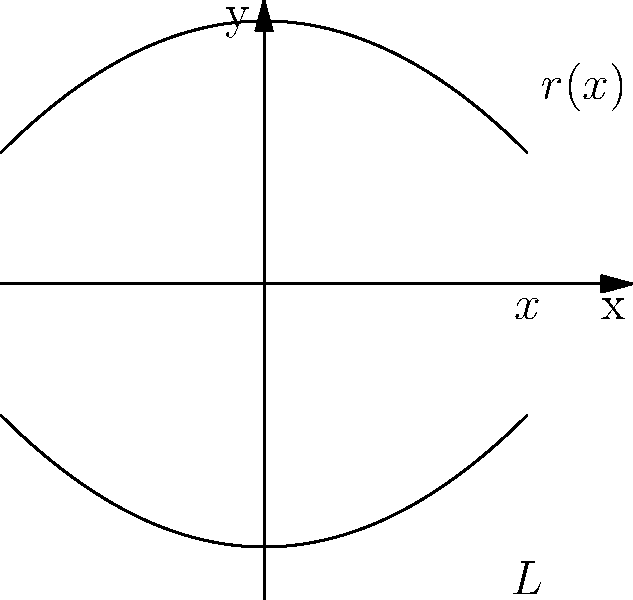A tapered blood vessel can be modeled as a vessel of length $L$ with radius $r(x) = \sqrt{4-x^2}$ mm, where $x$ is the distance along the vessel's axis. The flow rate $Q$ through a circular cross-section is given by $Q = k\pi r^4$, where $k$ is a constant. Determine the total flow rate through the vessel using calculus. To solve this problem, we need to integrate the flow rate over the length of the vessel. Here's a step-by-step approach:

1) The flow rate at any point $x$ is given by:
   $Q(x) = k\pi r(x)^4$

2) Substituting the given function for $r(x)$:
   $Q(x) = k\pi (\sqrt{4-x^2})^4 = k\pi (4-x^2)^2$

3) To find the total flow rate, we need to integrate $Q(x)$ over the length of the vessel:
   $Q_{total} = \int_0^L k\pi (4-x^2)^2 dx$

4) Factor out the constants:
   $Q_{total} = k\pi \int_0^L (4-x^2)^2 dx$

5) Expand $(4-x^2)^2$:
   $(4-x^2)^2 = 16 - 8x^2 + x^4$

6) Now our integral becomes:
   $Q_{total} = k\pi \int_0^L (16 - 8x^2 + x^4) dx$

7) Integrate term by term:
   $Q_{total} = k\pi [16x - \frac{8x^3}{3} + \frac{x^5}{5}]_0^L$

8) Evaluate the integral:
   $Q_{total} = k\pi (16L - \frac{8L^3}{3} + \frac{L^5}{5})$

This is the final expression for the total flow rate through the vessel.
Answer: $k\pi (16L - \frac{8L^3}{3} + \frac{L^5}{5})$ 